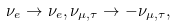Convert formula to latex. <formula><loc_0><loc_0><loc_500><loc_500>\nu _ { e } \to \nu _ { e } , \nu _ { \mu , \tau } \to - \nu _ { \mu , \tau } ,</formula> 